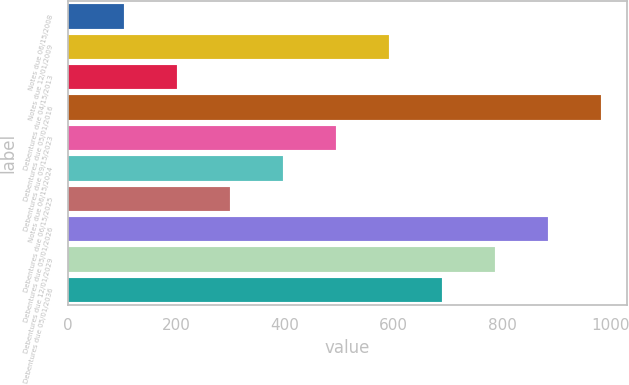Convert chart to OTSL. <chart><loc_0><loc_0><loc_500><loc_500><bar_chart><fcel>Notes due 06/15/2008<fcel>Notes due 12/01/2009<fcel>Debentures due 04/15/2013<fcel>Debentures due 05/01/2016<fcel>Debentures due 09/15/2023<fcel>Notes due 06/15/2024<fcel>Debentures due 06/15/2025<fcel>Debentures due 05/01/2026<fcel>Debentures due 12/01/2029<fcel>Debentures due 05/01/2036<nl><fcel>103<fcel>591<fcel>200.6<fcel>981.4<fcel>493.4<fcel>395.8<fcel>298.2<fcel>883.8<fcel>786.2<fcel>688.6<nl></chart> 